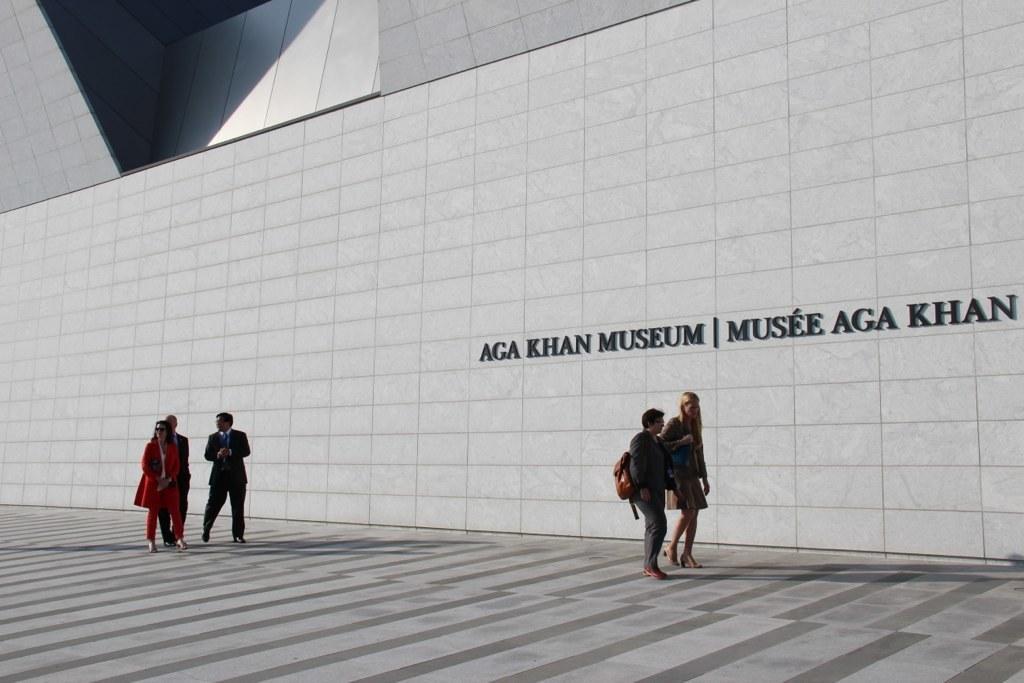Can you describe this image briefly? In this image we can see the wall with the name of the museum. We can also see a few people walking on the path. 